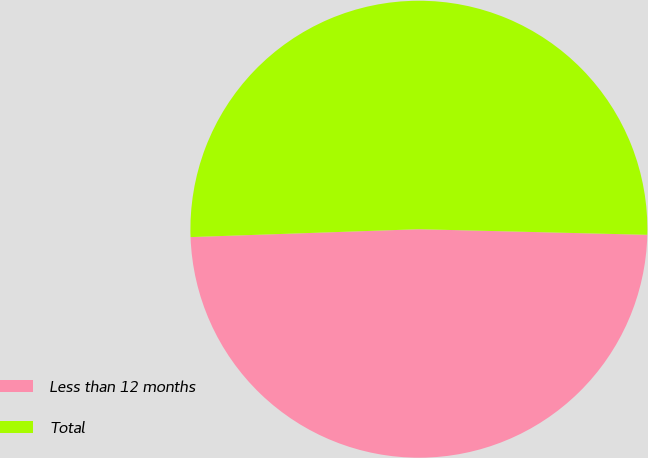Convert chart to OTSL. <chart><loc_0><loc_0><loc_500><loc_500><pie_chart><fcel>Less than 12 months<fcel>Total<nl><fcel>49.06%<fcel>50.94%<nl></chart> 